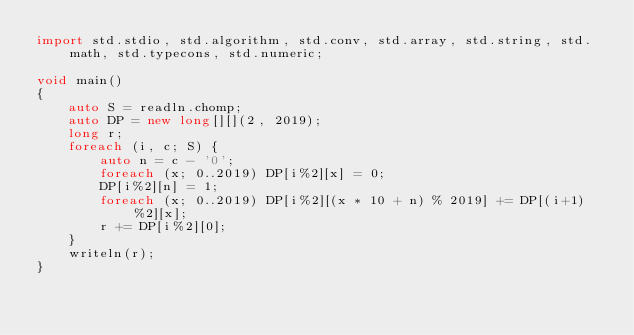<code> <loc_0><loc_0><loc_500><loc_500><_D_>import std.stdio, std.algorithm, std.conv, std.array, std.string, std.math, std.typecons, std.numeric;

void main()
{
    auto S = readln.chomp;
    auto DP = new long[][](2, 2019);
    long r;
    foreach (i, c; S) {
        auto n = c - '0';
        foreach (x; 0..2019) DP[i%2][x] = 0;
        DP[i%2][n] = 1;
        foreach (x; 0..2019) DP[i%2][(x * 10 + n) % 2019] += DP[(i+1)%2][x];
        r += DP[i%2][0];
    }
    writeln(r);
}</code> 